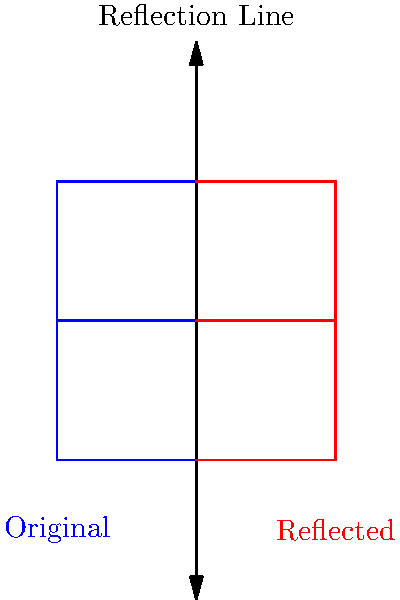In the image above, a letter "E" is reflected across a vertical line. What would happen to the letter "B" if it were reflected in the same way? Choose the best description:

a) It would appear backwards but still recognizable as "B"
b) It would look exactly the same as the original "B"
c) It would transform into a different letter
d) It would become unreadable Let's think about this step-by-step:

1. Reflection across a vertical line means that each point of the original shape is moved to the opposite side of the line, maintaining the same distance from the line.

2. For a letter "B":
   - The straight vertical line on the left side of "B" would move to the right side.
   - The curved parts on the right side would move to the left side.

3. This transformation would result in:
   - The straight part now being on the right.
   - The curved parts now being on the left.

4. The overall shape would still resemble a "B", but it would appear backwards or reversed.

5. This is similar to how the "E" in the image is still recognizable as an "E", but appears backwards after reflection.

6. The reflection doesn't change the letter into a different one, nor does it make it unreadable. It simply reverses its orientation.

Therefore, the best description is that the reflected "B" would appear backwards but still be recognizable as a "B".
Answer: a) It would appear backwards but still recognizable as "B" 